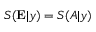Convert formula to latex. <formula><loc_0><loc_0><loc_500><loc_500>S ( E | y ) = S ( A | y )</formula> 